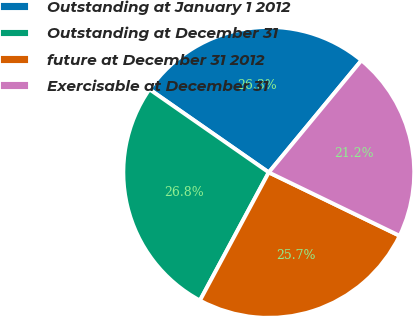<chart> <loc_0><loc_0><loc_500><loc_500><pie_chart><fcel>Outstanding at January 1 2012<fcel>Outstanding at December 31<fcel>future at December 31 2012<fcel>Exercisable at December 31<nl><fcel>26.32%<fcel>26.83%<fcel>25.67%<fcel>21.18%<nl></chart> 